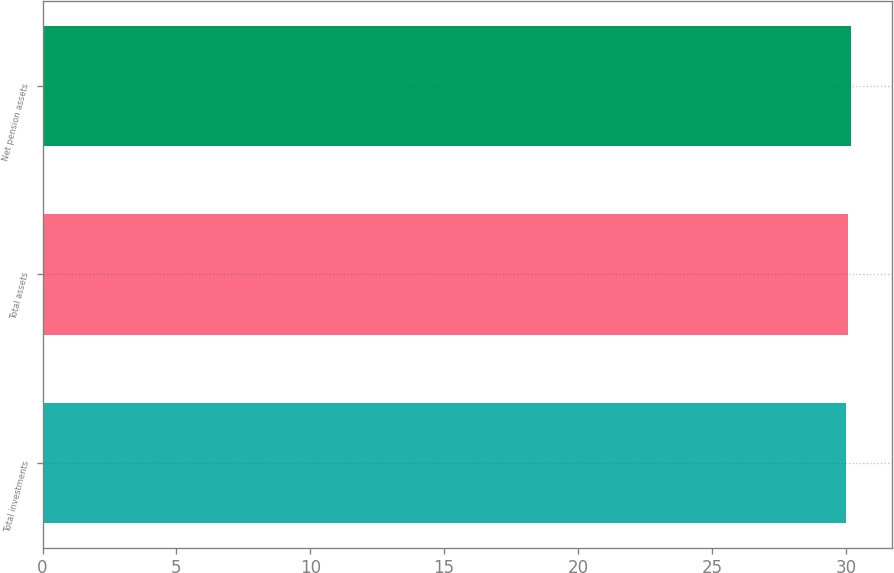Convert chart. <chart><loc_0><loc_0><loc_500><loc_500><bar_chart><fcel>Total investments<fcel>Total assets<fcel>Net pension assets<nl><fcel>30<fcel>30.1<fcel>30.2<nl></chart> 